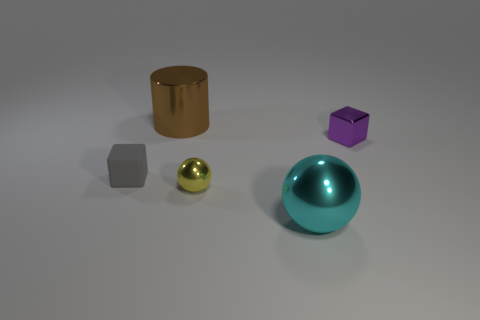Add 4 small green balls. How many objects exist? 9 Subtract all cylinders. How many objects are left? 4 Subtract 0 purple balls. How many objects are left? 5 Subtract all big red shiny things. Subtract all big metal objects. How many objects are left? 3 Add 4 yellow things. How many yellow things are left? 5 Add 1 small rubber blocks. How many small rubber blocks exist? 2 